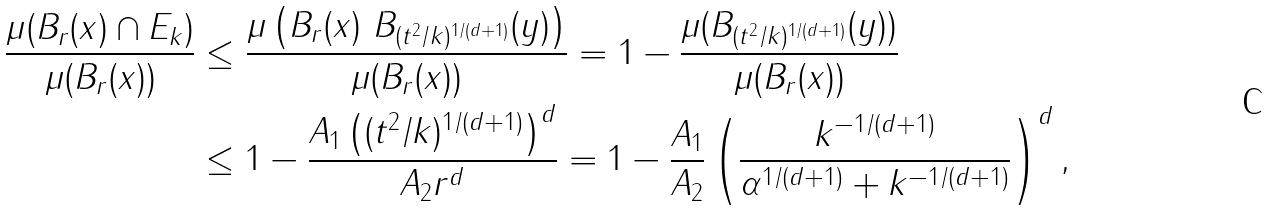<formula> <loc_0><loc_0><loc_500><loc_500>\frac { \mu ( B _ { r } ( x ) \cap E _ { k } ) } { \mu ( B _ { r } ( x ) ) } & \leq \frac { \mu \left ( B _ { r } ( x ) \ B _ { ( t ^ { 2 } / k ) ^ { 1 / ( d + 1 ) } } ( y ) \right ) } { \mu ( B _ { r } ( x ) ) } = 1 - \frac { \mu ( B _ { ( t ^ { 2 } / k ) ^ { 1 / ( d + 1 ) } } ( y ) ) } { \mu ( B _ { r } ( x ) ) } \\ & \leq 1 - \frac { A _ { 1 } \left ( ( t ^ { 2 } / k ) ^ { 1 / ( d + 1 ) } \right ) ^ { d } } { A _ { 2 } r ^ { d } } = 1 - \frac { A _ { 1 } } { A _ { 2 } } \left ( \frac { k ^ { - 1 / ( d + 1 ) } } { \alpha ^ { 1 / ( d + 1 ) } + k ^ { - 1 / ( d + 1 ) } } \right ) ^ { d } ,</formula> 